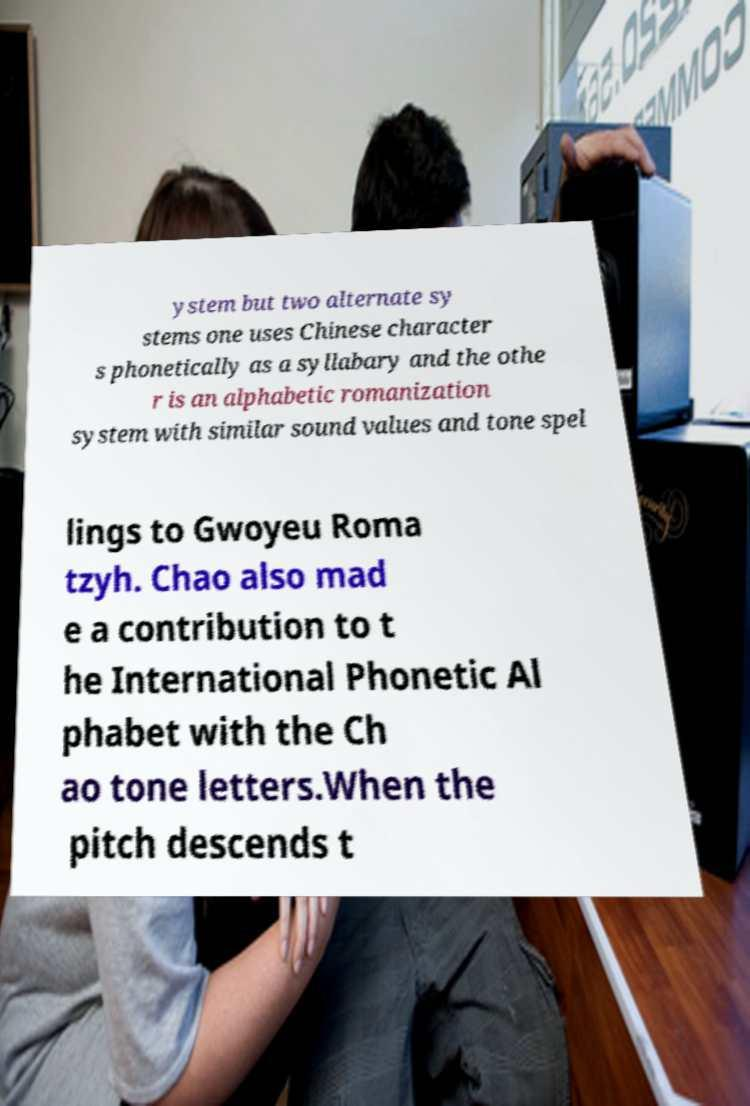There's text embedded in this image that I need extracted. Can you transcribe it verbatim? ystem but two alternate sy stems one uses Chinese character s phonetically as a syllabary and the othe r is an alphabetic romanization system with similar sound values and tone spel lings to Gwoyeu Roma tzyh. Chao also mad e a contribution to t he International Phonetic Al phabet with the Ch ao tone letters.When the pitch descends t 